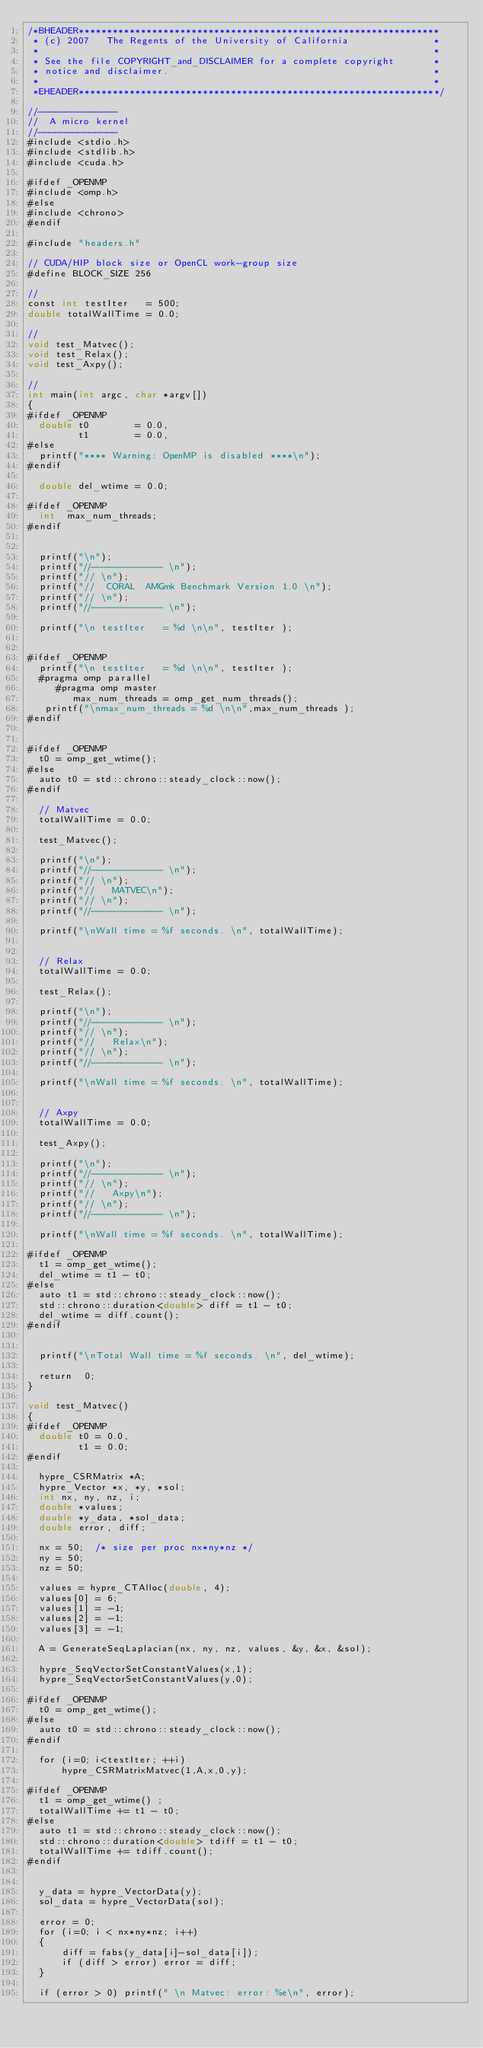Convert code to text. <code><loc_0><loc_0><loc_500><loc_500><_Cuda_>/*BHEADER****************************************************************
 * (c) 2007   The Regents of the University of California               *
 *                                                                      *
 * See the file COPYRIGHT_and_DISCLAIMER for a complete copyright       *
 * notice and disclaimer.                                               *
 *                                                                      *
 *EHEADER****************************************************************/

//--------------
//  A micro kernel 
//--------------
#include <stdio.h>
#include <stdlib.h>
#include <cuda.h>

#ifdef _OPENMP
#include <omp.h>
#else
#include <chrono>
#endif

#include "headers.h"

// CUDA/HIP block size or OpenCL work-group size
#define BLOCK_SIZE 256

// 
const int testIter   = 500;
double totalWallTime = 0.0;

// 
void test_Matvec();
void test_Relax();
void test_Axpy();

//
int main(int argc, char *argv[])
{
#ifdef _OPENMP
  double t0        = 0.0,
         t1        = 0.0,
#else
  printf("**** Warning: OpenMP is disabled ****\n");
#endif

  double del_wtime = 0.0;

#ifdef _OPENMP
  int  max_num_threads;
#endif


  printf("\n");
  printf("//------------ \n");
  printf("// \n");
  printf("//  CORAL  AMGmk Benchmark Version 1.0 \n");
  printf("// \n");
  printf("//------------ \n");

  printf("\n testIter   = %d \n\n", testIter );  

 
#ifdef _OPENMP
  printf("\n testIter   = %d \n\n", testIter );  
  #pragma omp parallel
     #pragma omp master
        max_num_threads = omp_get_num_threads();
   printf("\nmax_num_threads = %d \n\n",max_num_threads );
#endif


#ifdef _OPENMP
  t0 = omp_get_wtime();
#else
  auto t0 = std::chrono::steady_clock::now();
#endif

  // Matvec
  totalWallTime = 0.0;
 
  test_Matvec();

  printf("\n");
  printf("//------------ \n");
  printf("// \n");
  printf("//   MATVEC\n");
  printf("// \n");
  printf("//------------ \n");

  printf("\nWall time = %f seconds. \n", totalWallTime);


  // Relax
  totalWallTime = 0.0;

  test_Relax();

  printf("\n");
  printf("//------------ \n");
  printf("// \n");
  printf("//   Relax\n");
  printf("// \n");
  printf("//------------ \n");

  printf("\nWall time = %f seconds. \n", totalWallTime);


  // Axpy
  totalWallTime = 0.0;
 
  test_Axpy();

  printf("\n");
  printf("//------------ \n");
  printf("// \n");
  printf("//   Axpy\n");
  printf("// \n");
  printf("//------------ \n");

  printf("\nWall time = %f seconds. \n", totalWallTime);

#ifdef _OPENMP
  t1 = omp_get_wtime();
  del_wtime = t1 - t0;
#else
  auto t1 = std::chrono::steady_clock::now();
  std::chrono::duration<double> diff = t1 - t0;
  del_wtime = diff.count();
#endif


  printf("\nTotal Wall time = %f seconds. \n", del_wtime);

  return  0;
}

void test_Matvec()
{
#ifdef _OPENMP
  double t0 = 0.0,
         t1 = 0.0;
#endif

  hypre_CSRMatrix *A;
  hypre_Vector *x, *y, *sol;
  int nx, ny, nz, i;
  double *values;
  double *y_data, *sol_data;
  double error, diff;

  nx = 50;  /* size per proc nx*ny*nz */
  ny = 50;
  nz = 50;

  values = hypre_CTAlloc(double, 4);
  values[0] = 6; 
  values[1] = -1;
  values[2] = -1;
  values[3] = -1;

  A = GenerateSeqLaplacian(nx, ny, nz, values, &y, &x, &sol);

  hypre_SeqVectorSetConstantValues(x,1);
  hypre_SeqVectorSetConstantValues(y,0);

#ifdef _OPENMP
  t0 = omp_get_wtime();
#else
  auto t0 = std::chrono::steady_clock::now();
#endif

  for (i=0; i<testIter; ++i)
      hypre_CSRMatrixMatvec(1,A,x,0,y);

#ifdef _OPENMP
  t1 = omp_get_wtime() ;
  totalWallTime += t1 - t0;
#else
  auto t1 = std::chrono::steady_clock::now();
  std::chrono::duration<double> tdiff = t1 - t0;
  totalWallTime += tdiff.count();
#endif

 
  y_data = hypre_VectorData(y);
  sol_data = hypre_VectorData(sol);

  error = 0;
  for (i=0; i < nx*ny*nz; i++)
  {
      diff = fabs(y_data[i]-sol_data[i]);
      if (diff > error) error = diff;
  }
     
  if (error > 0) printf(" \n Matvec: error: %e\n", error);
</code> 